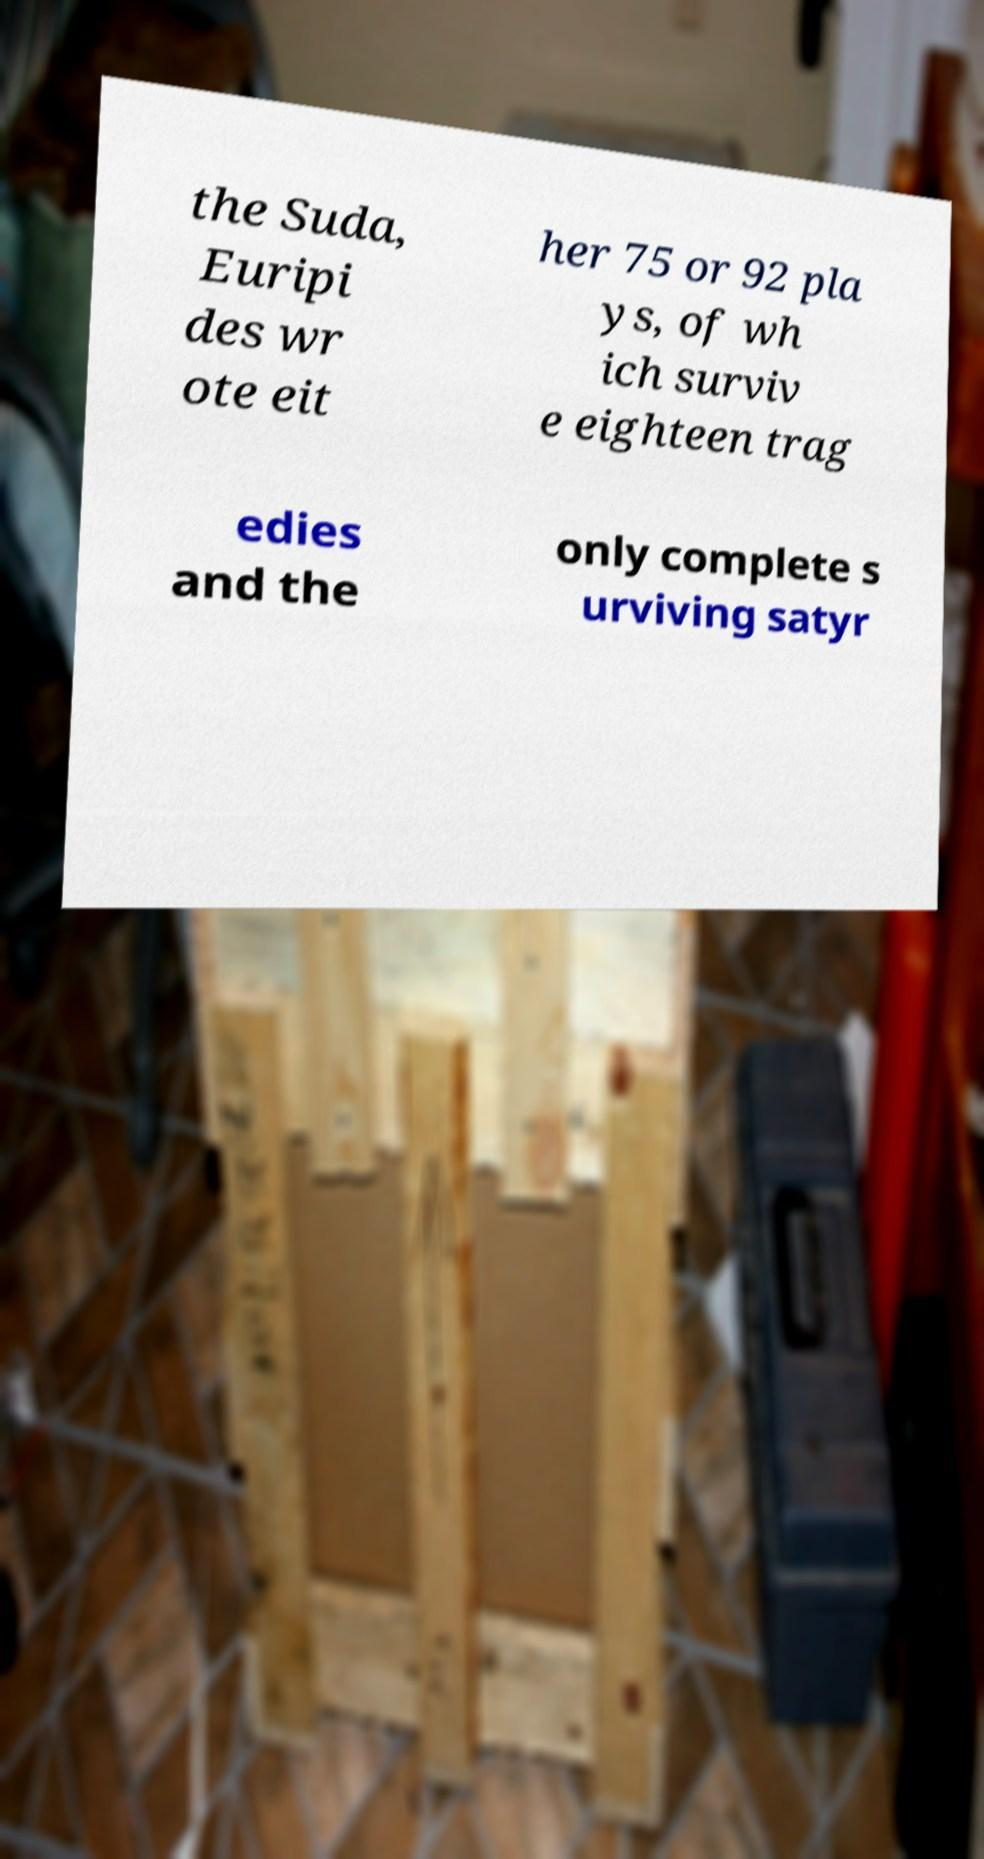I need the written content from this picture converted into text. Can you do that? the Suda, Euripi des wr ote eit her 75 or 92 pla ys, of wh ich surviv e eighteen trag edies and the only complete s urviving satyr 